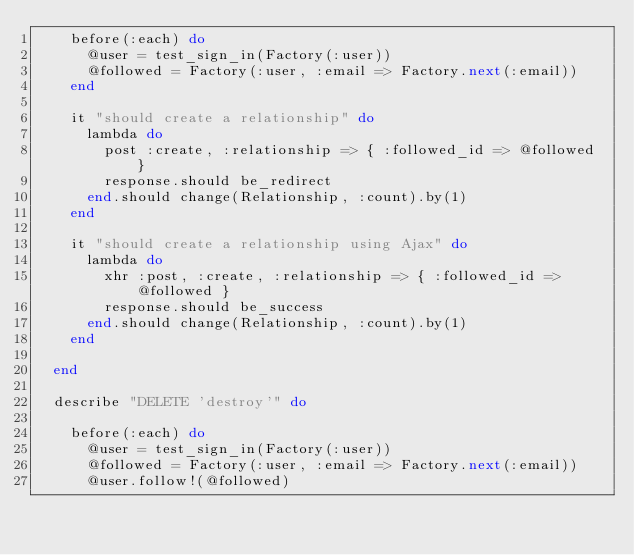<code> <loc_0><loc_0><loc_500><loc_500><_Ruby_>    before(:each) do
      @user = test_sign_in(Factory(:user))
      @followed = Factory(:user, :email => Factory.next(:email))
    end
    
    it "should create a relationship" do
      lambda do
        post :create, :relationship => { :followed_id => @followed }
        response.should be_redirect
      end.should change(Relationship, :count).by(1)
    end
    
    it "should create a relationship using Ajax" do
      lambda do
        xhr :post, :create, :relationship => { :followed_id => @followed }
        response.should be_success
      end.should change(Relationship, :count).by(1)
    end
        
  end
  
  describe "DELETE 'destroy'" do
    
    before(:each) do
      @user = test_sign_in(Factory(:user))
      @followed = Factory(:user, :email => Factory.next(:email))
      @user.follow!(@followed)</code> 